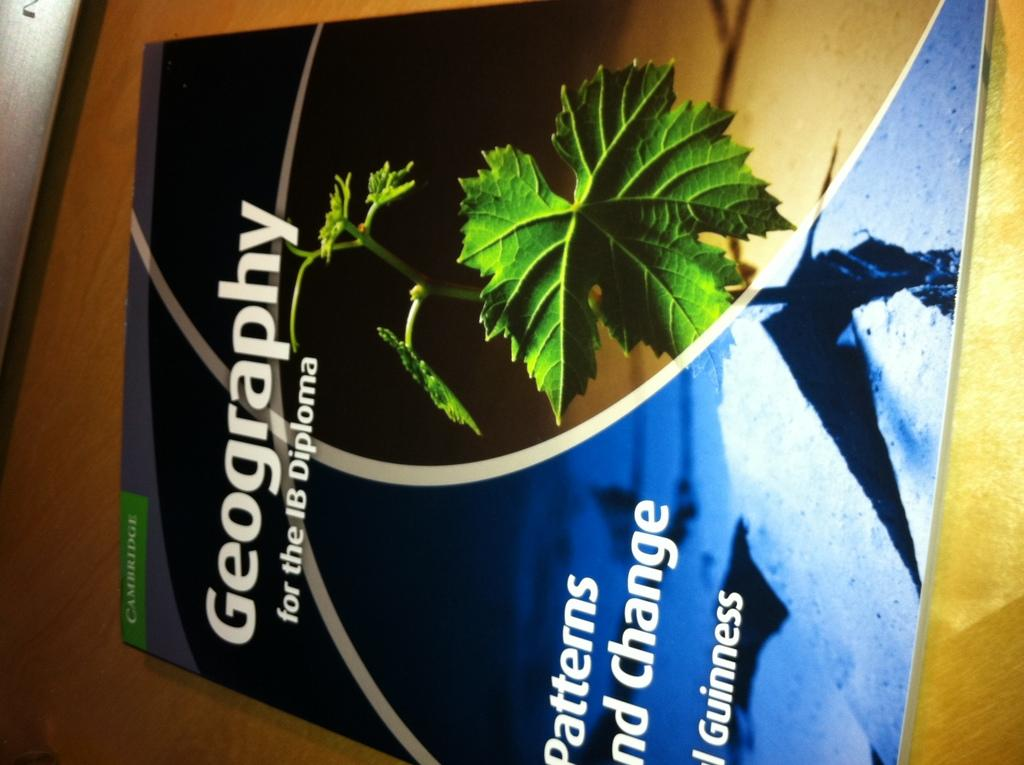Provide a one-sentence caption for the provided image. A pamphlet titled, "Geography" has a picture of a leaf on it. 